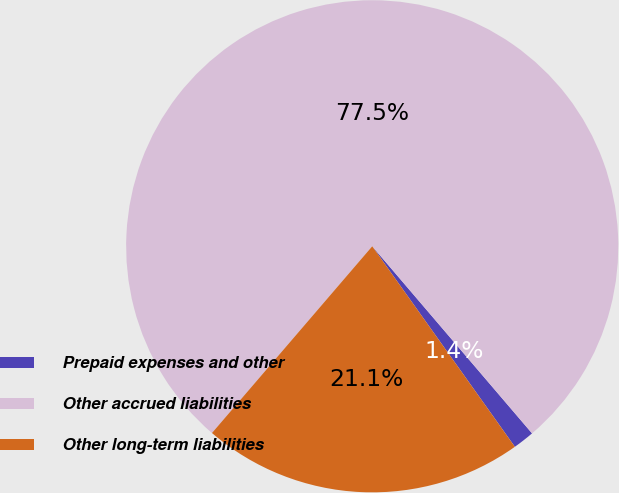<chart> <loc_0><loc_0><loc_500><loc_500><pie_chart><fcel>Prepaid expenses and other<fcel>Other accrued liabilities<fcel>Other long-term liabilities<nl><fcel>1.41%<fcel>77.46%<fcel>21.13%<nl></chart> 